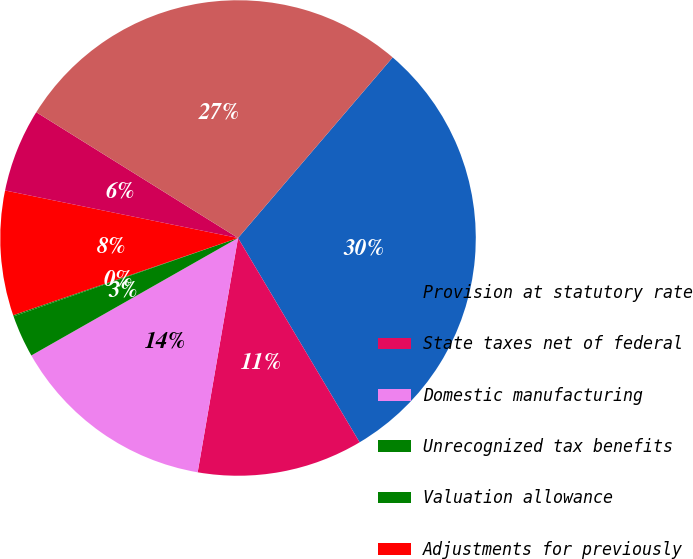<chart> <loc_0><loc_0><loc_500><loc_500><pie_chart><fcel>Provision at statutory rate<fcel>State taxes net of federal<fcel>Domestic manufacturing<fcel>Unrecognized tax benefits<fcel>Valuation allowance<fcel>Adjustments for previously<fcel>Other<fcel>Provision for income taxes<nl><fcel>30.19%<fcel>11.26%<fcel>14.06%<fcel>2.88%<fcel>0.08%<fcel>8.47%<fcel>5.67%<fcel>27.4%<nl></chart> 